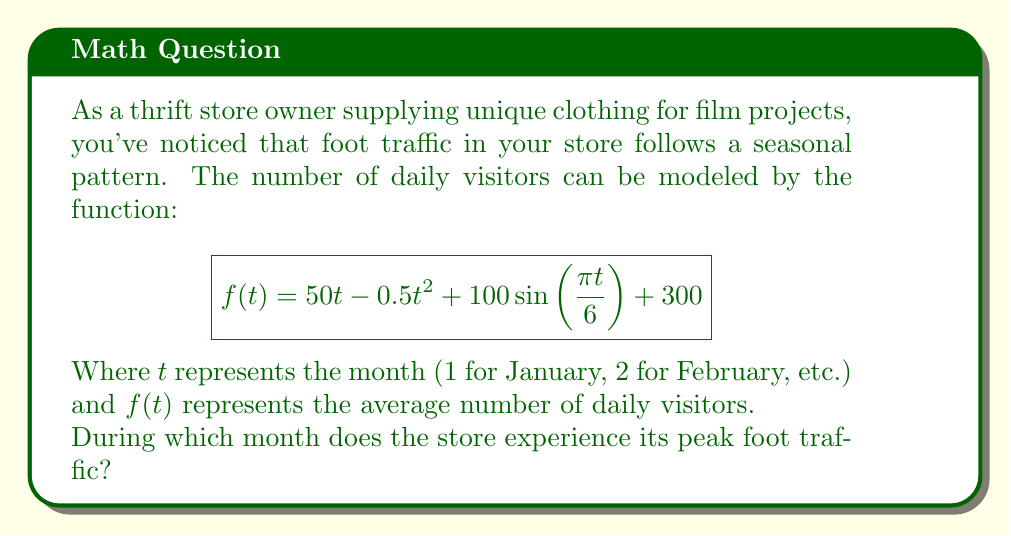Provide a solution to this math problem. To find the month with peak foot traffic, we need to determine the maximum value of $f(t)$ for $t$ between 1 and 12 (representing the 12 months of the year).

1) First, let's break down the function:
   - $50t - 0.5t^2$ is a quadratic function
   - $100\sin(\frac{\pi t}{6})$ is the sinusoidal component
   - 300 is a constant offset

2) The sinusoidal component has a period of 12 months, peaking at $t = 3$ and $t = 9$ (March and September).

3) The quadratic component $50t - 0.5t^2$ reaches its maximum at $t = 50$ (which is outside our range of interest).

4) To find the exact maximum, we could differentiate $f(t)$ and set it to zero, but this leads to a complex equation due to the sinusoidal term.

5) Instead, let's evaluate $f(t)$ for each month and compare:

   $f(1) \approx 449$
   $f(2) \approx 591$
   $f(3) \approx 723$
   $f(4) \approx 839$
   $f(5) \approx 935$
   $f(6) \approx 1007$
   $f(7) \approx 1051$
   $f(8) \approx 1065$
   $f(9) \approx 1048$
   $f(10) \approx 998$
   $f(11) \approx 914$
   $f(12) \approx 796$

6) The maximum value occurs when $t = 8$, corresponding to August.
Answer: August 